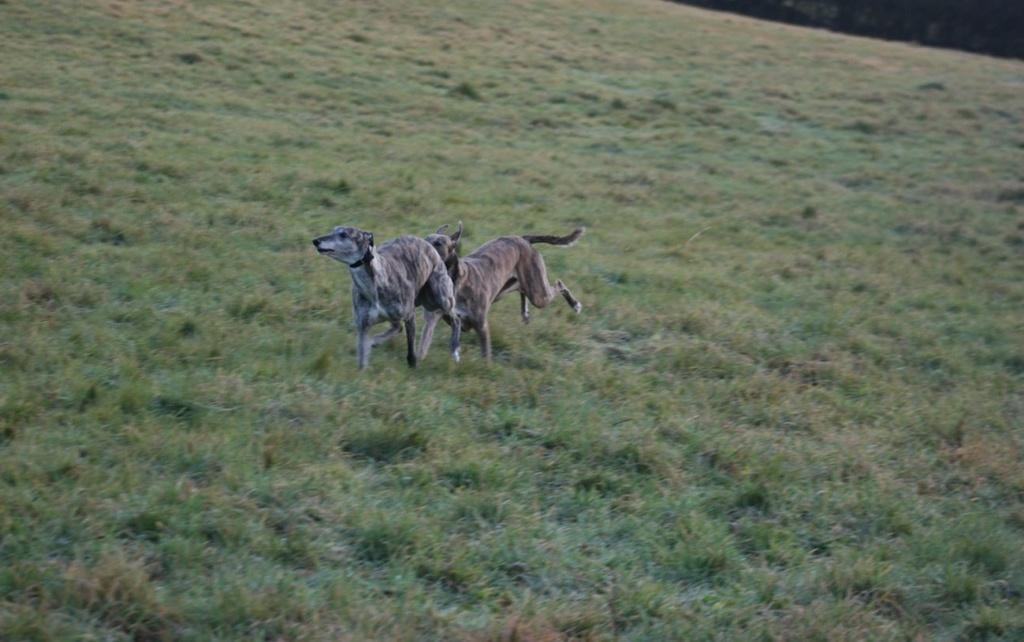What animals are in the center of the image? There are two dogs in the center of the image. What type of environment is visible in the background of the image? There is grass visible in the background of the image. What is the answer to the question posed by the team in the image? There is no question or team present in the image, so it is not possible to answer that question. 